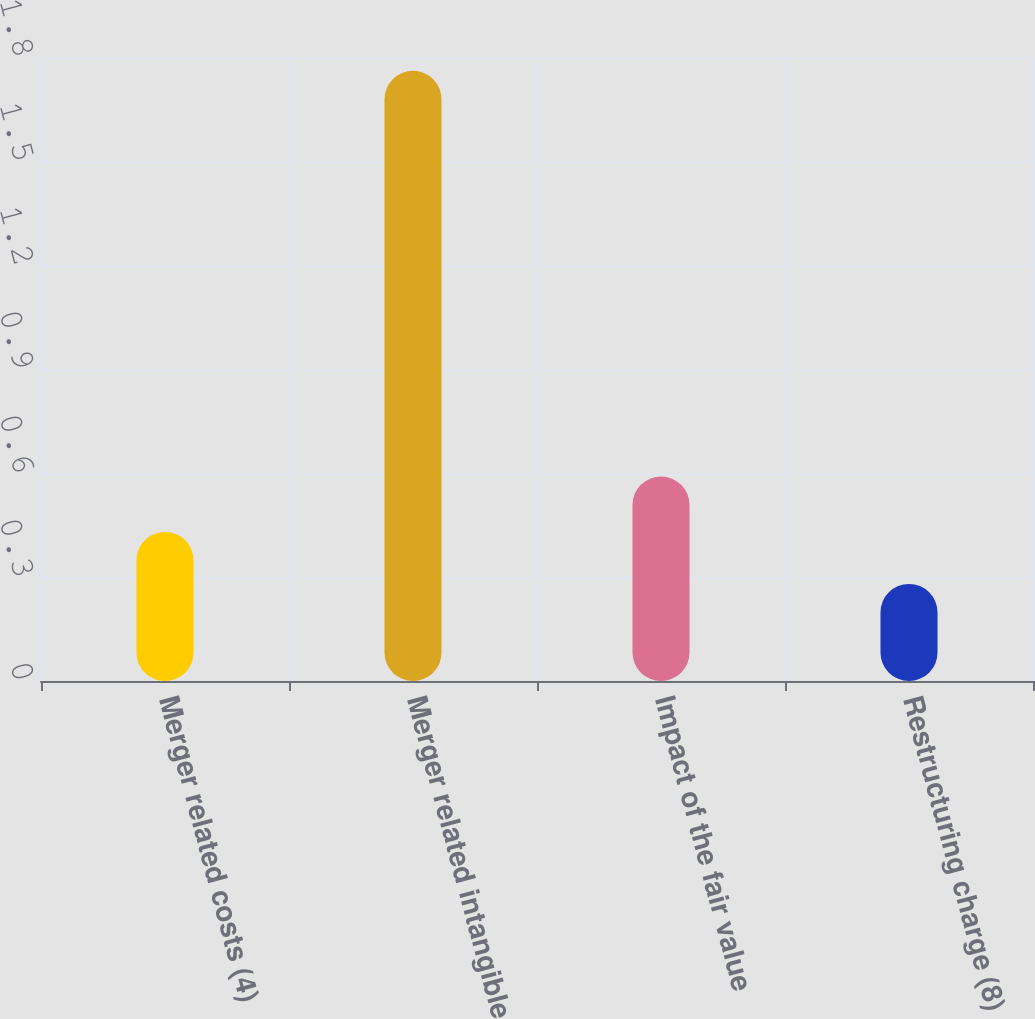Convert chart to OTSL. <chart><loc_0><loc_0><loc_500><loc_500><bar_chart><fcel>Merger related costs (4)<fcel>Merger related intangible<fcel>Impact of the fair value<fcel>Restructuring charge (8)<nl><fcel>0.43<fcel>1.76<fcel>0.59<fcel>0.28<nl></chart> 